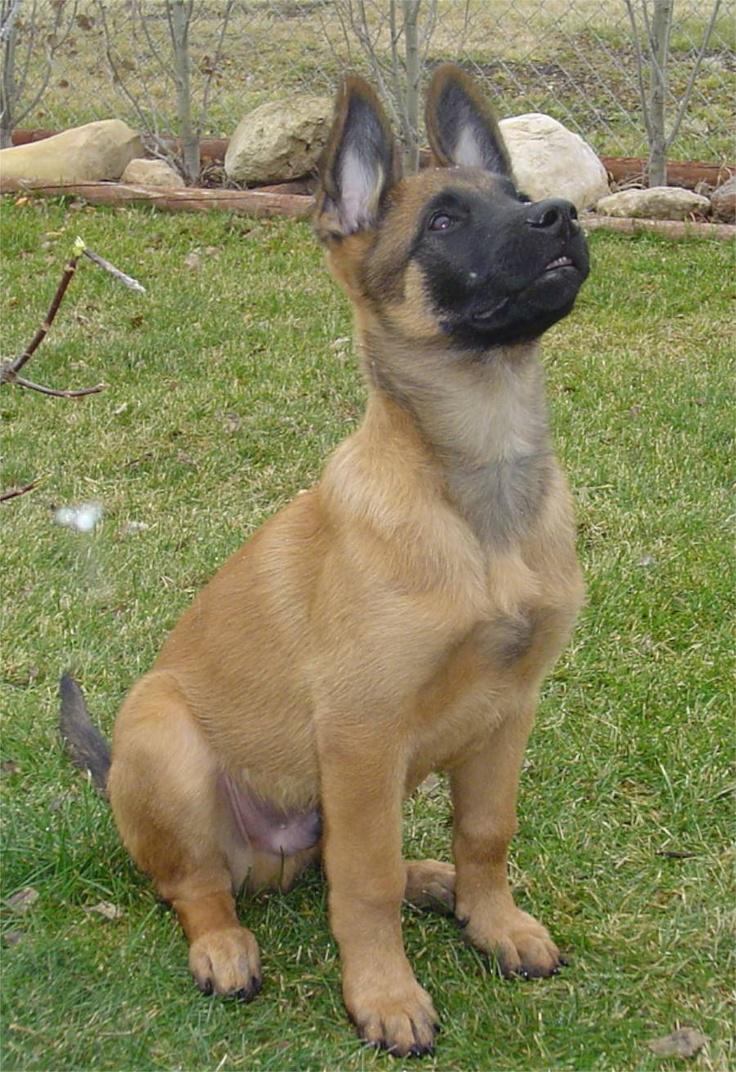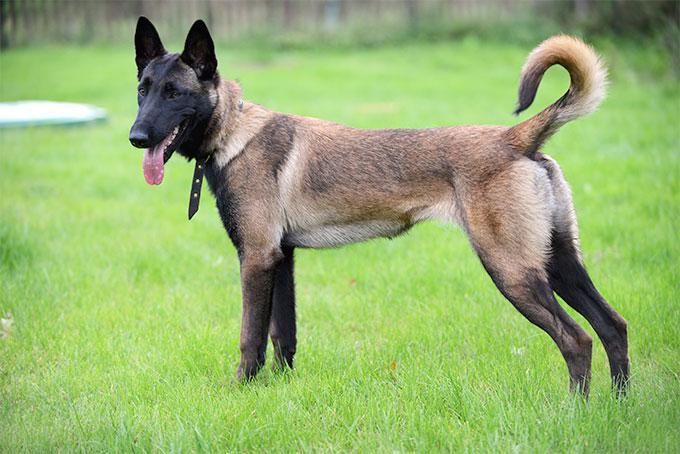The first image is the image on the left, the second image is the image on the right. Considering the images on both sides, is "A dog is pictured against a plain white backgroun." valid? Answer yes or no. No. 